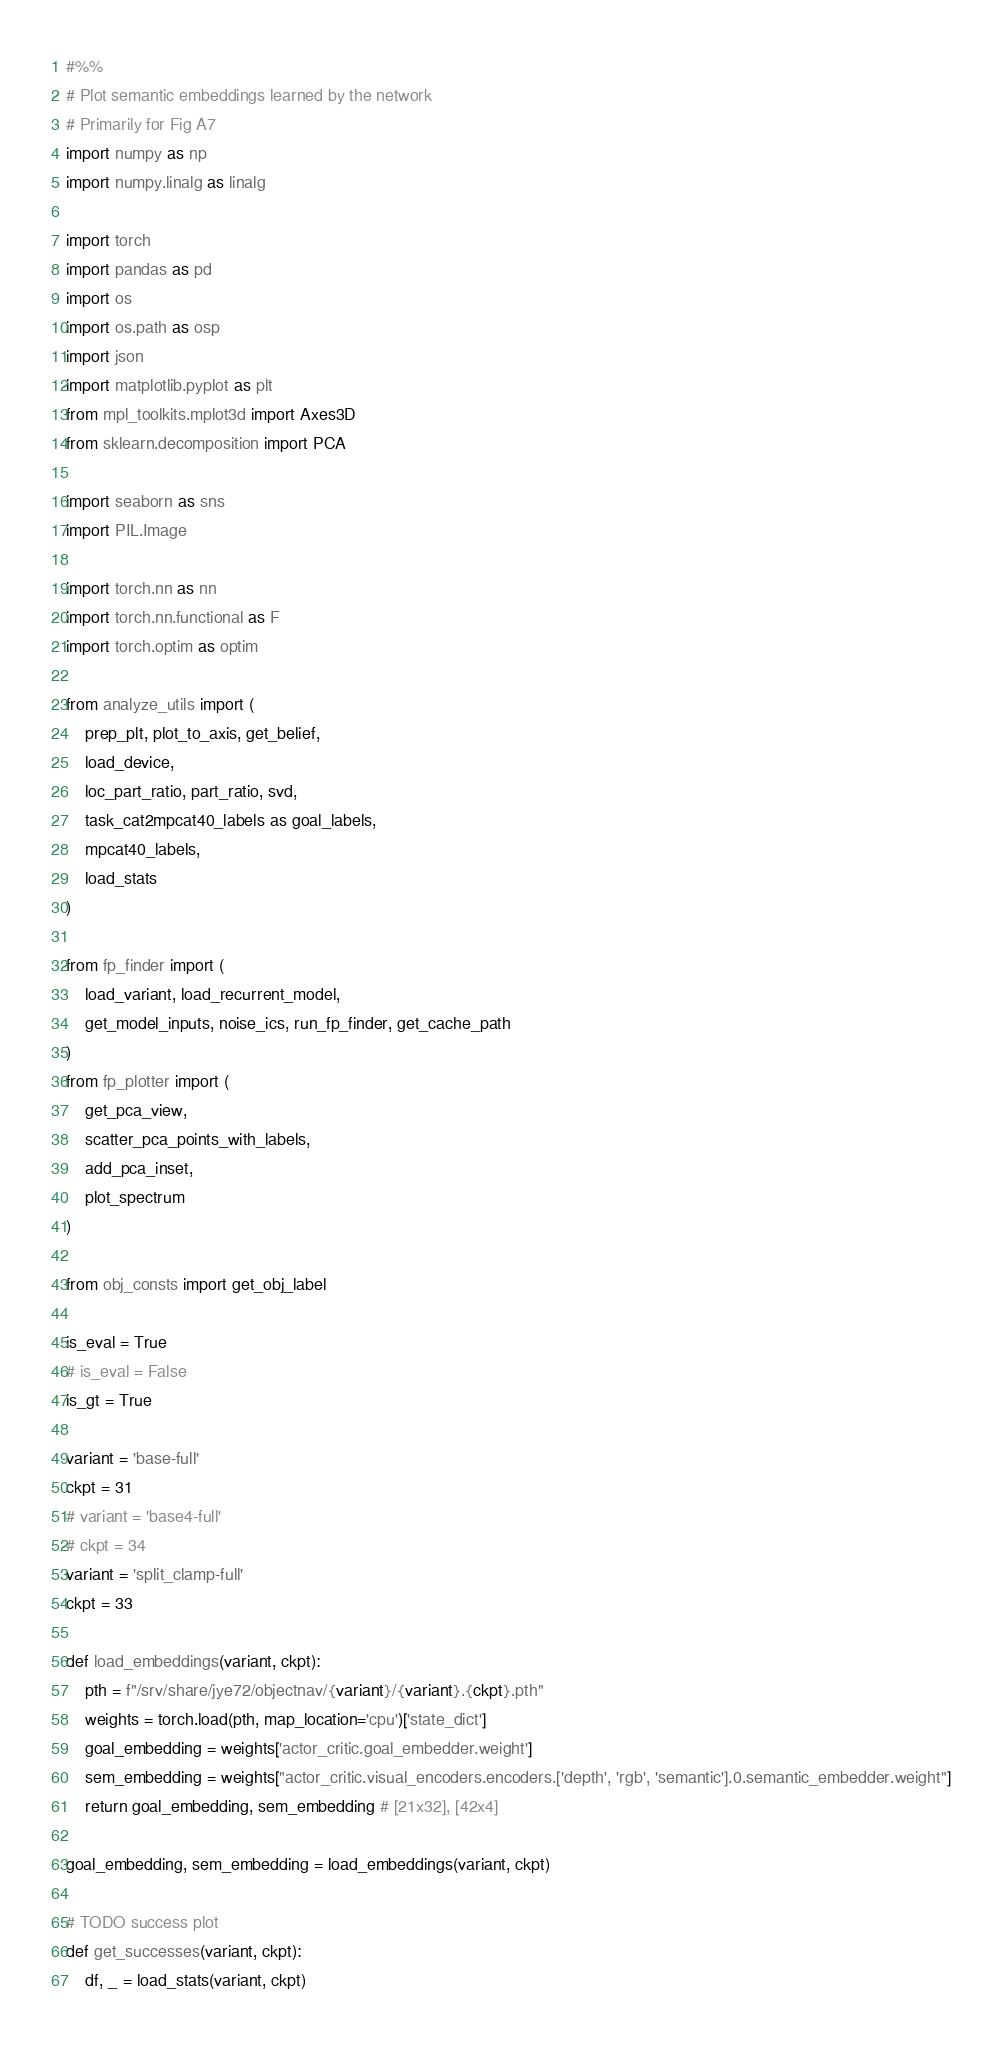<code> <loc_0><loc_0><loc_500><loc_500><_Python_>#%%
# Plot semantic embeddings learned by the network
# Primarily for Fig A7
import numpy as np
import numpy.linalg as linalg

import torch
import pandas as pd
import os
import os.path as osp
import json
import matplotlib.pyplot as plt
from mpl_toolkits.mplot3d import Axes3D
from sklearn.decomposition import PCA

import seaborn as sns
import PIL.Image

import torch.nn as nn
import torch.nn.functional as F
import torch.optim as optim

from analyze_utils import (
    prep_plt, plot_to_axis, get_belief,
    load_device,
    loc_part_ratio, part_ratio, svd,
    task_cat2mpcat40_labels as goal_labels,
    mpcat40_labels,
    load_stats
)

from fp_finder import (
    load_variant, load_recurrent_model,
    get_model_inputs, noise_ics, run_fp_finder, get_cache_path
)
from fp_plotter import (
    get_pca_view,
    scatter_pca_points_with_labels,
    add_pca_inset,
    plot_spectrum
)

from obj_consts import get_obj_label

is_eval = True
# is_eval = False
is_gt = True

variant = 'base-full'
ckpt = 31
# variant = 'base4-full'
# ckpt = 34
variant = 'split_clamp-full'
ckpt = 33

def load_embeddings(variant, ckpt):
    pth = f"/srv/share/jye72/objectnav/{variant}/{variant}.{ckpt}.pth"
    weights = torch.load(pth, map_location='cpu')['state_dict']
    goal_embedding = weights['actor_critic.goal_embedder.weight']
    sem_embedding = weights["actor_critic.visual_encoders.encoders.['depth', 'rgb', 'semantic'].0.semantic_embedder.weight"]
    return goal_embedding, sem_embedding # [21x32], [42x4]

goal_embedding, sem_embedding = load_embeddings(variant, ckpt)

# TODO success plot
def get_successes(variant, ckpt):
    df, _ = load_stats(variant, ckpt)</code> 